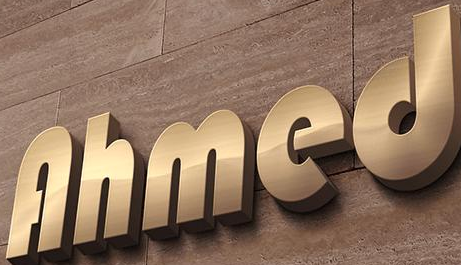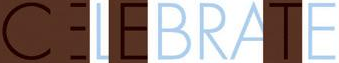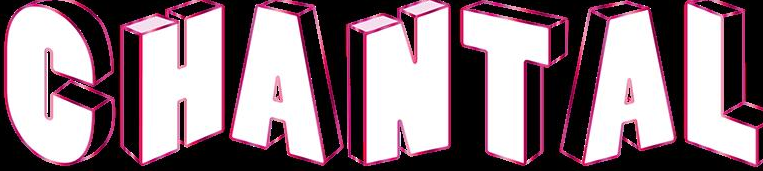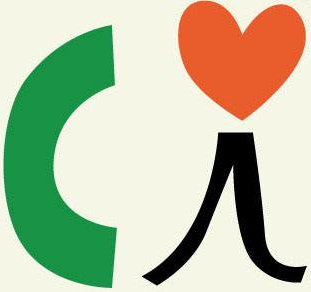What words can you see in these images in sequence, separated by a semicolon? Ahmed; CELEBRATE; CHANTAL; Ci 